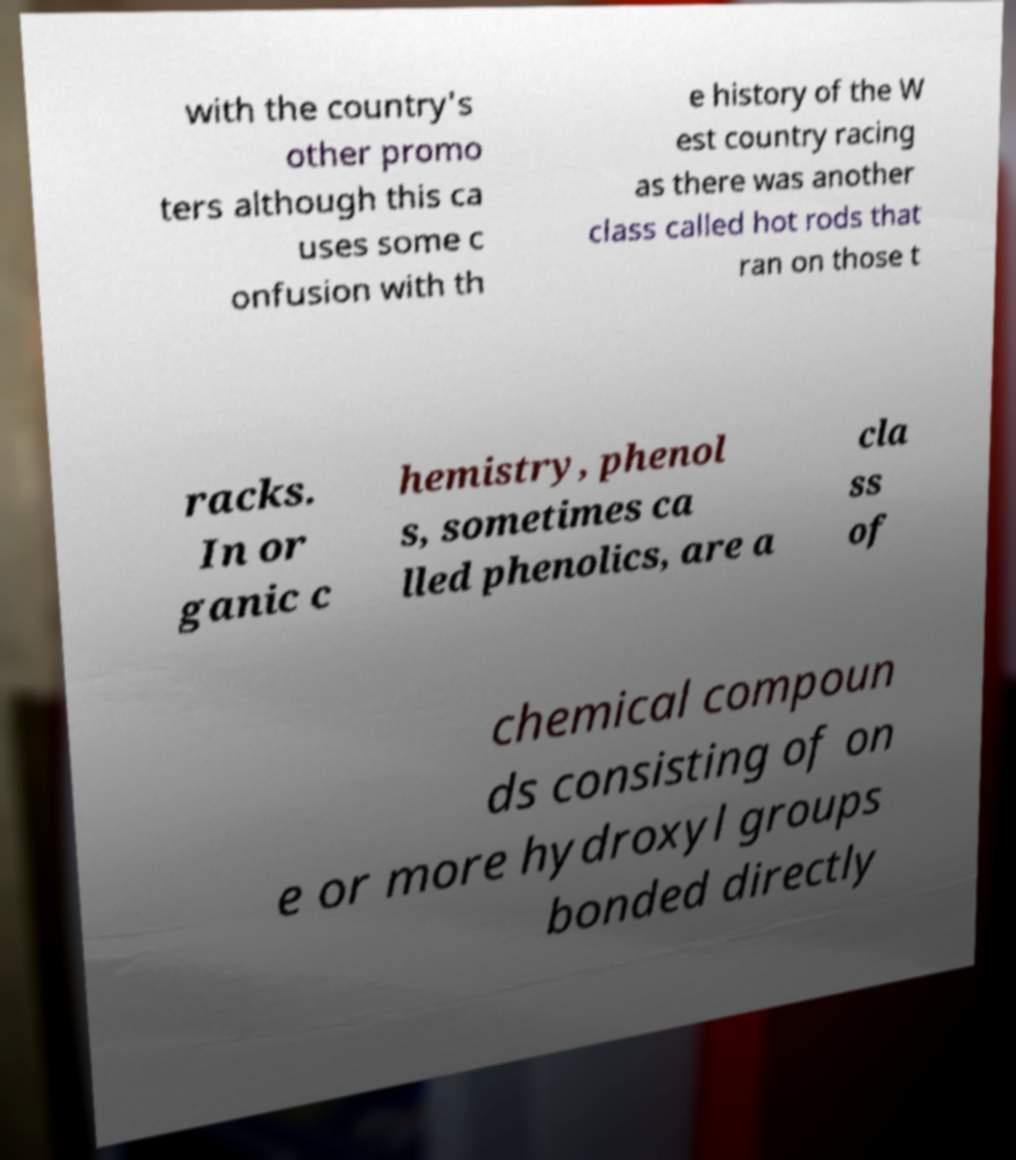What messages or text are displayed in this image? I need them in a readable, typed format. with the country's other promo ters although this ca uses some c onfusion with th e history of the W est country racing as there was another class called hot rods that ran on those t racks. In or ganic c hemistry, phenol s, sometimes ca lled phenolics, are a cla ss of chemical compoun ds consisting of on e or more hydroxyl groups bonded directly 